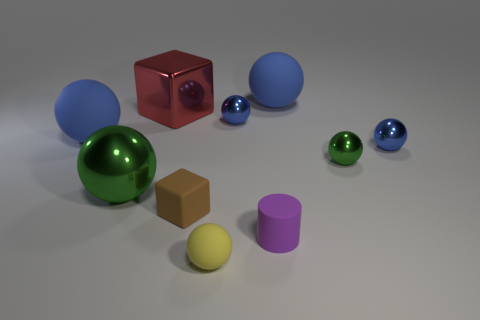Is the shape of the blue matte thing that is on the right side of the small purple matte cylinder the same as the green metal object on the left side of the small brown rubber cube?
Keep it short and to the point. Yes. There is a small green shiny ball right of the large rubber ball that is on the right side of the matte cube; are there any matte objects that are in front of it?
Your answer should be very brief. Yes. Does the tiny purple cylinder have the same material as the tiny green thing?
Offer a very short reply. No. Is there any other thing that has the same shape as the tiny brown rubber object?
Keep it short and to the point. Yes. There is a large blue object that is right of the green thing that is to the left of the red shiny thing; what is its material?
Make the answer very short. Rubber. There is a blue matte object that is on the right side of the large green metal sphere; how big is it?
Make the answer very short. Large. There is a matte ball that is behind the small cube and on the right side of the large green metal sphere; what color is it?
Offer a very short reply. Blue. There is a rubber ball in front of the purple matte cylinder; is it the same size as the small green metallic ball?
Provide a succinct answer. Yes. There is a green metallic object on the right side of the large metallic block; is there a small object that is behind it?
Ensure brevity in your answer.  Yes. What material is the brown thing?
Provide a succinct answer. Rubber. 